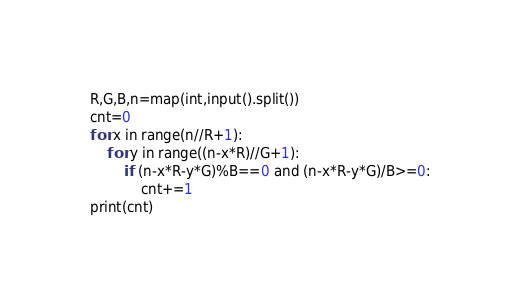Convert code to text. <code><loc_0><loc_0><loc_500><loc_500><_Python_>R,G,B,n=map(int,input().split())
cnt=0
for x in range(n//R+1):
    for y in range((n-x*R)//G+1):
        if (n-x*R-y*G)%B==0 and (n-x*R-y*G)/B>=0:
            cnt+=1
print(cnt)</code> 